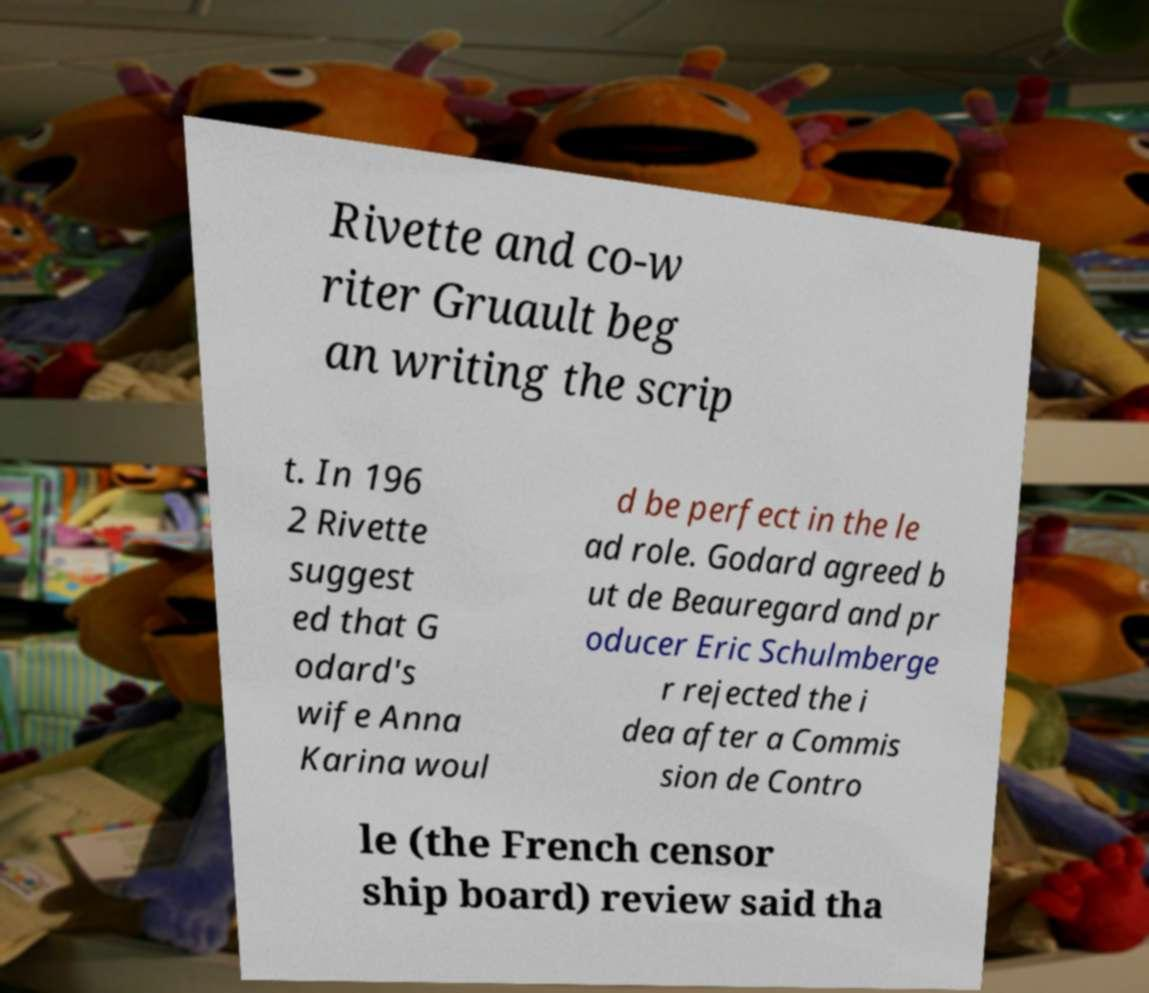Can you read and provide the text displayed in the image?This photo seems to have some interesting text. Can you extract and type it out for me? Rivette and co-w riter Gruault beg an writing the scrip t. In 196 2 Rivette suggest ed that G odard's wife Anna Karina woul d be perfect in the le ad role. Godard agreed b ut de Beauregard and pr oducer Eric Schulmberge r rejected the i dea after a Commis sion de Contro le (the French censor ship board) review said tha 